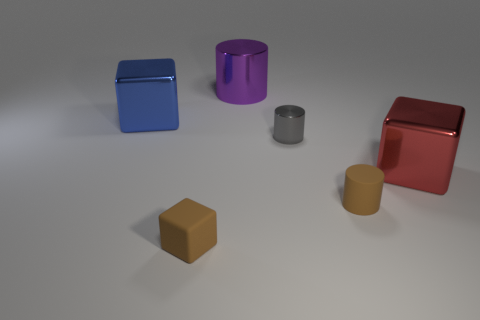Subtract all blue cylinders. Subtract all cyan blocks. How many cylinders are left? 3 Add 2 purple cylinders. How many objects exist? 8 Subtract all purple cylinders. Subtract all purple cylinders. How many objects are left? 4 Add 4 brown rubber cubes. How many brown rubber cubes are left? 5 Add 1 red spheres. How many red spheres exist? 1 Subtract 0 purple balls. How many objects are left? 6 